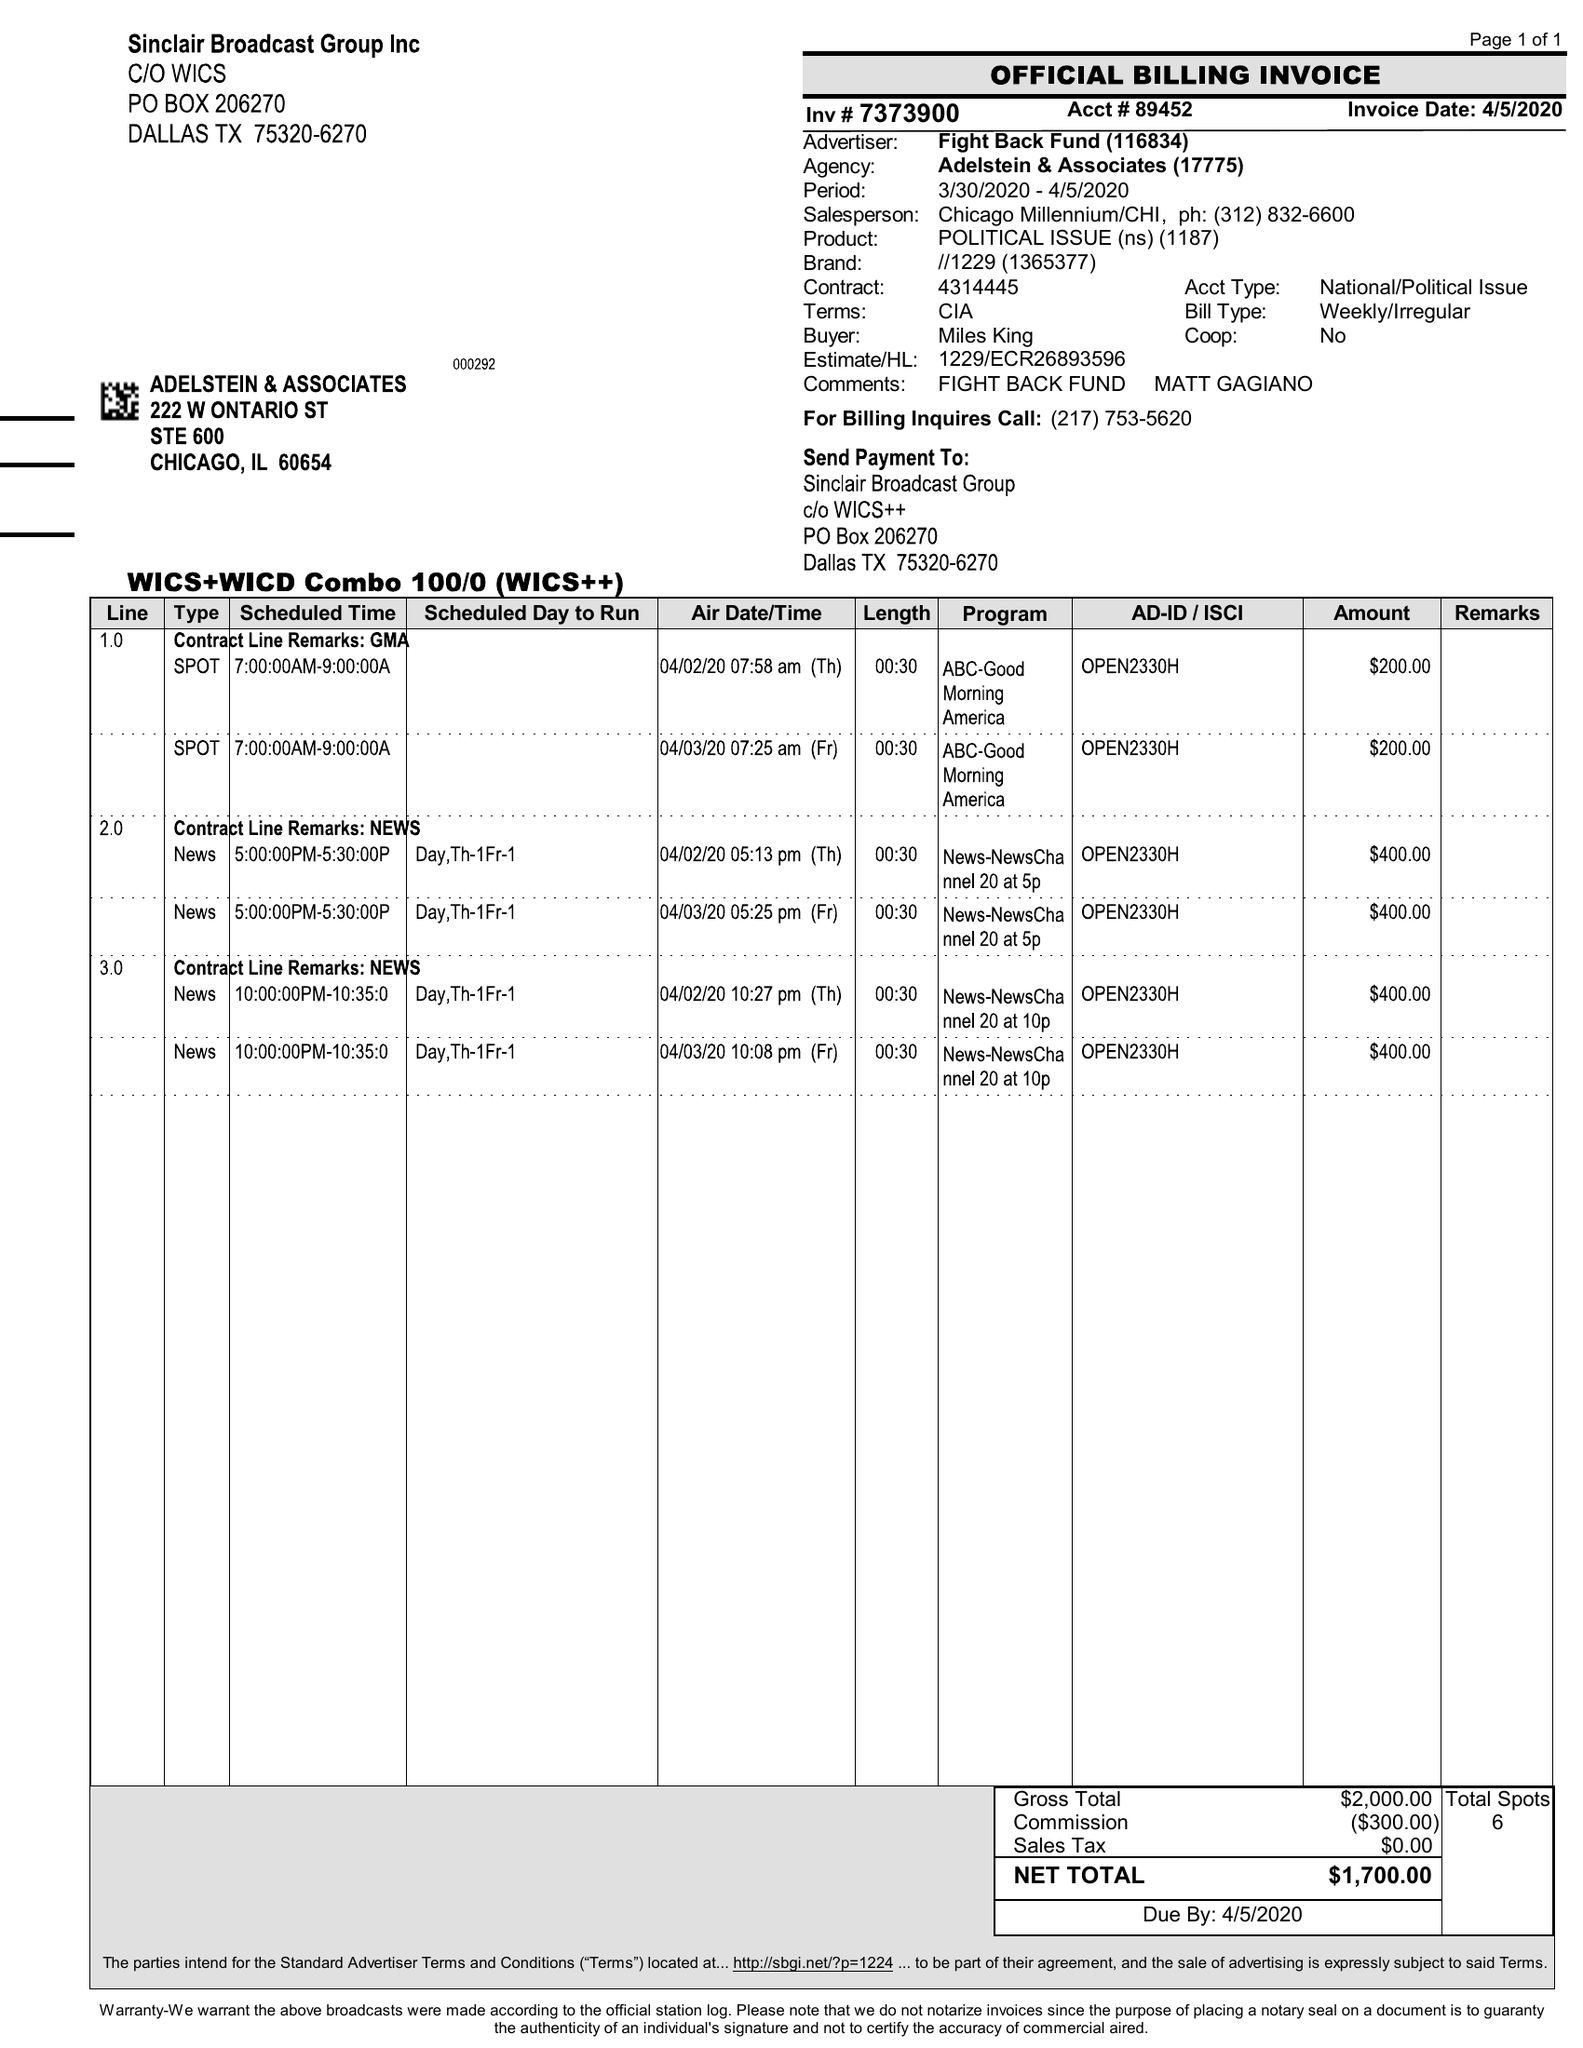What is the value for the flight_from?
Answer the question using a single word or phrase. 03/30/20 